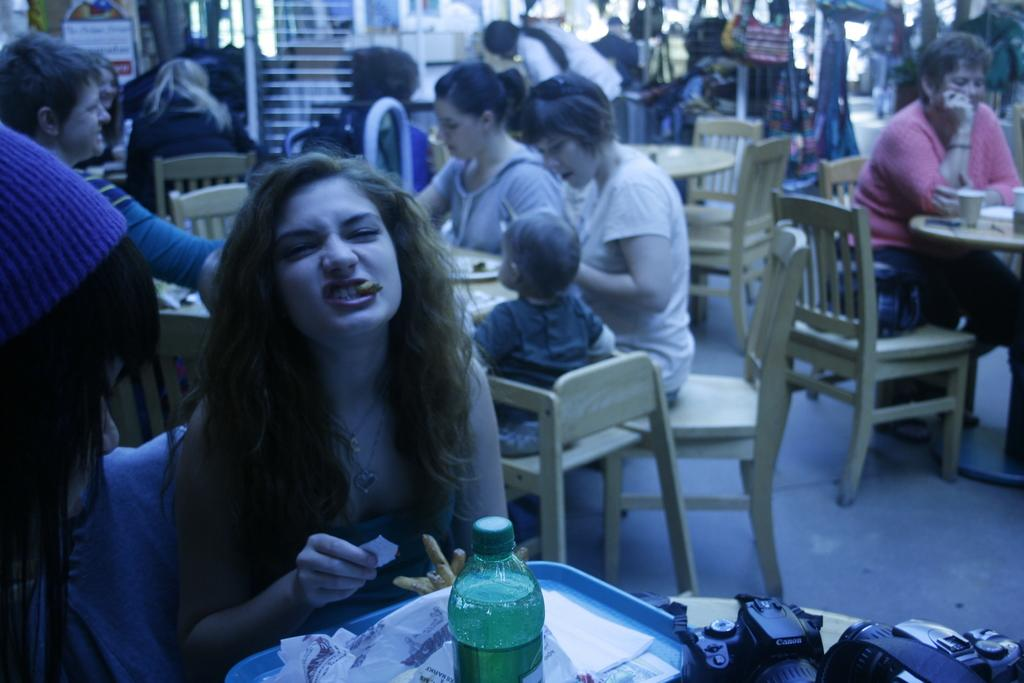What is the person in the image doing? The person is having food in the image. What is placed in front of the person? There is a bottle and a camera in front of the person. What can be seen in the background of the image? There are many tables and chairs behind the person, and people are sitting on them. Can you see the person's toes in the image? There is no indication of the person's toes being visible in the image. 